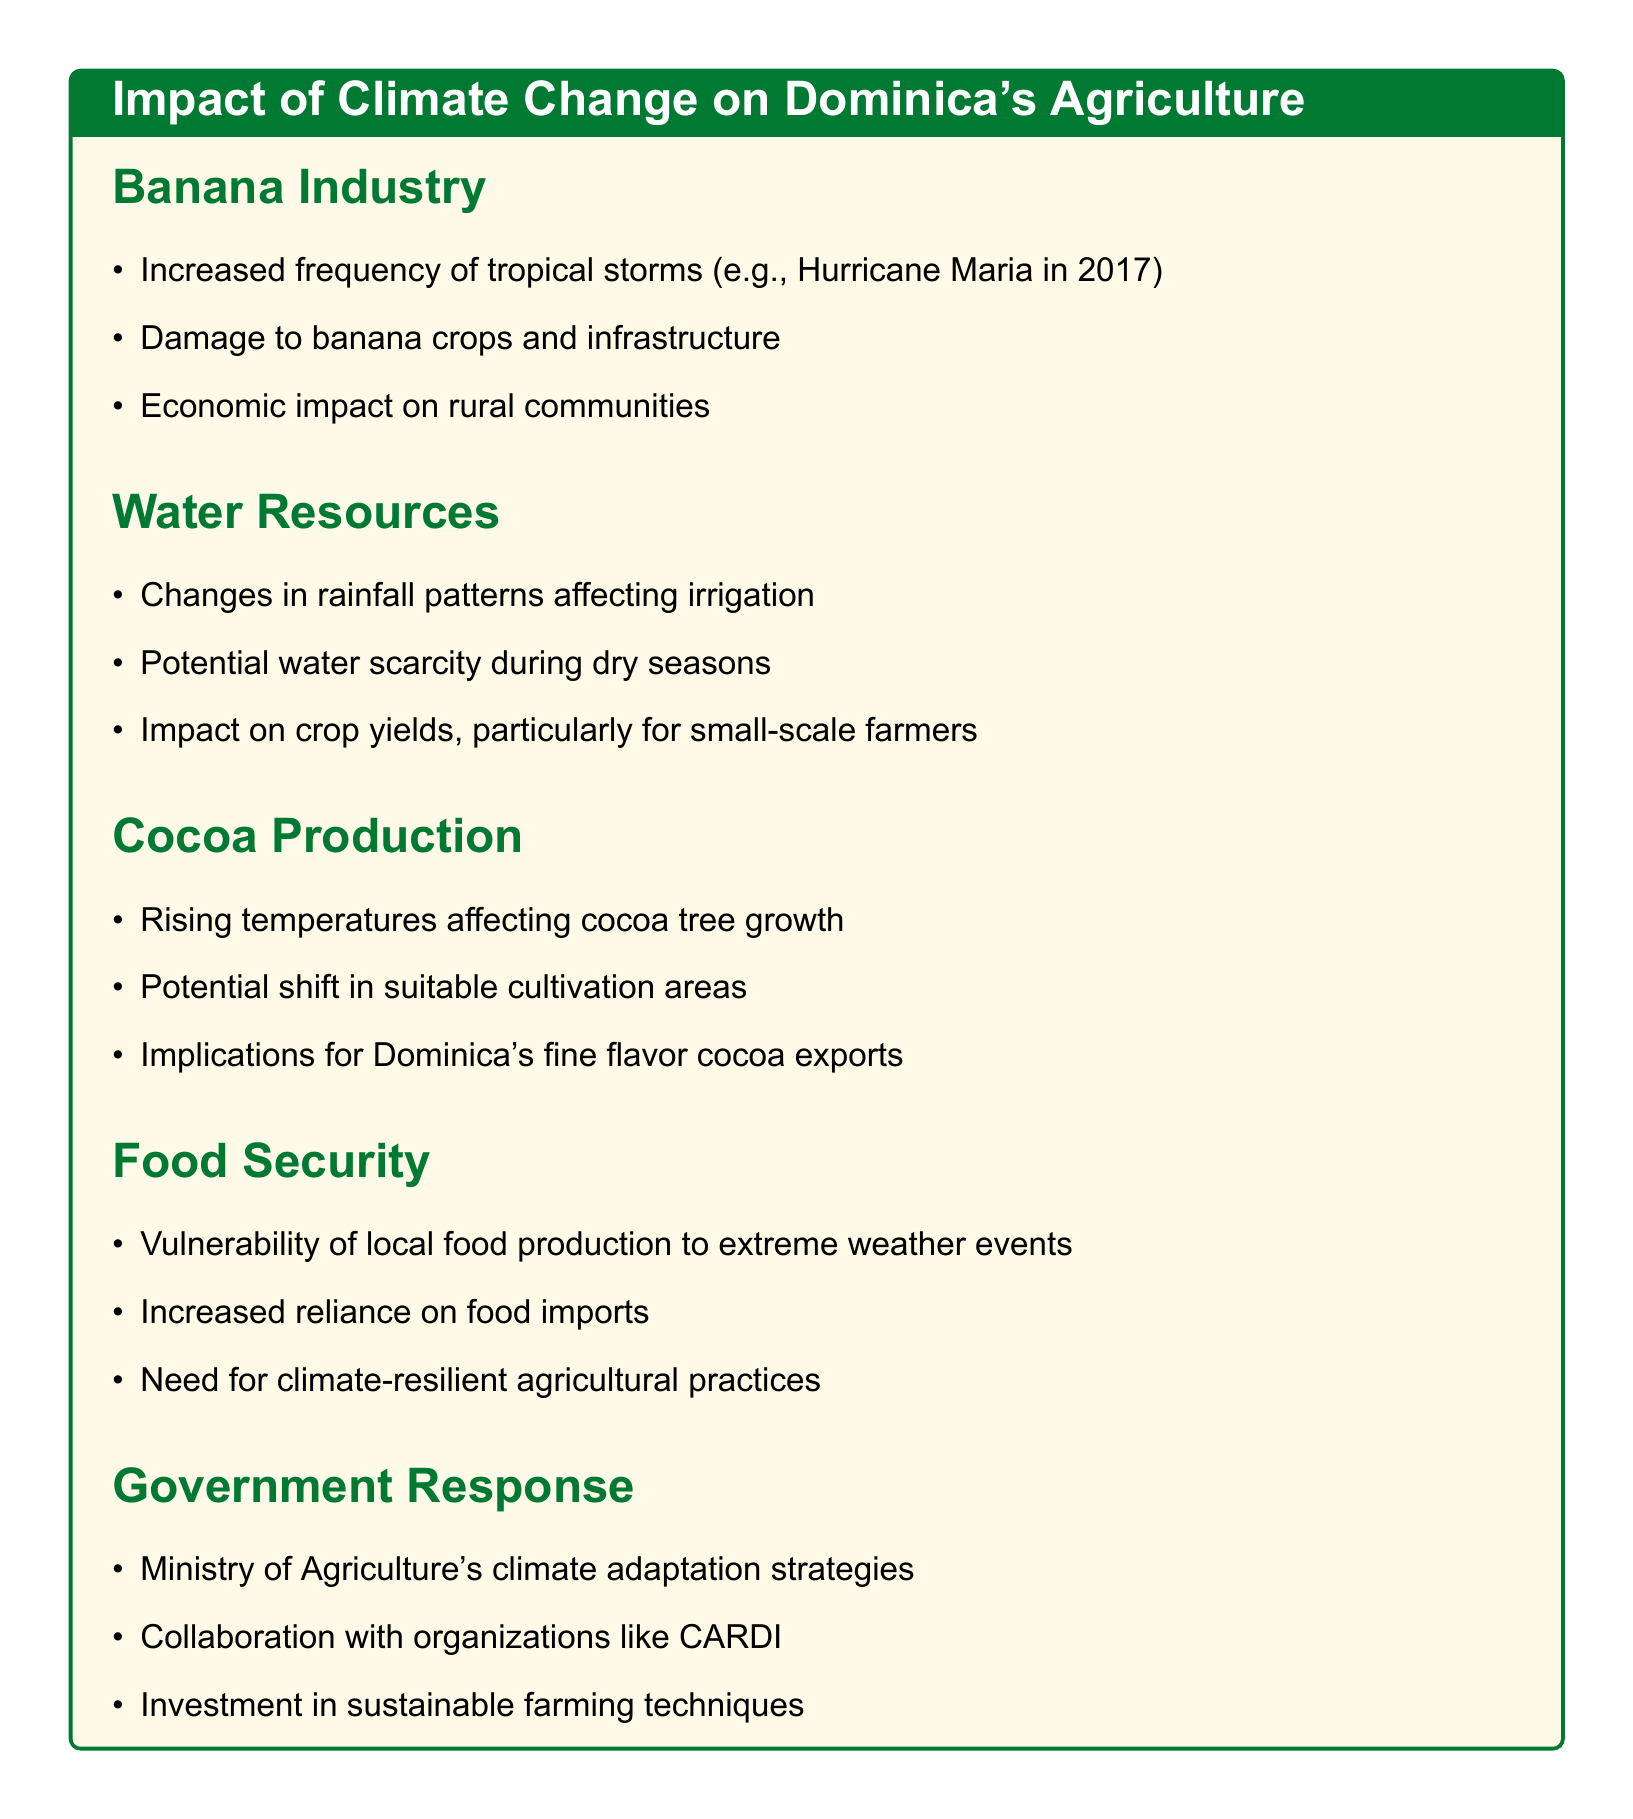What major storm impacted the banana industry in 2017? The document mentions Hurricane Maria as a significant storm that affected the banana industry in 2017.
Answer: Hurricane Maria What is one consequence of changes in rainfall patterns on agriculture? The document states that changes in rainfall patterns affect irrigation, which is a key consequence.
Answer: Irrigation How do rising temperatures affect cocoa production? According to the document, rising temperatures affect cocoa tree growth, indicating a direct impact on production.
Answer: Cocoa tree growth What vulnerability does local food production face due to climate change? The document highlights the vulnerability of local food production to extreme weather events as a significant concern.
Answer: Extreme weather events What organization collaborates with the Ministry of Agriculture on climate adaptation strategies? The document identifies CARDI (Caribbean Agricultural Research and Development Institute) as a collaborating organization.
Answer: CARDI 